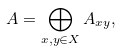Convert formula to latex. <formula><loc_0><loc_0><loc_500><loc_500>A = \bigoplus _ { x , y \in X } A _ { x y } ,</formula> 